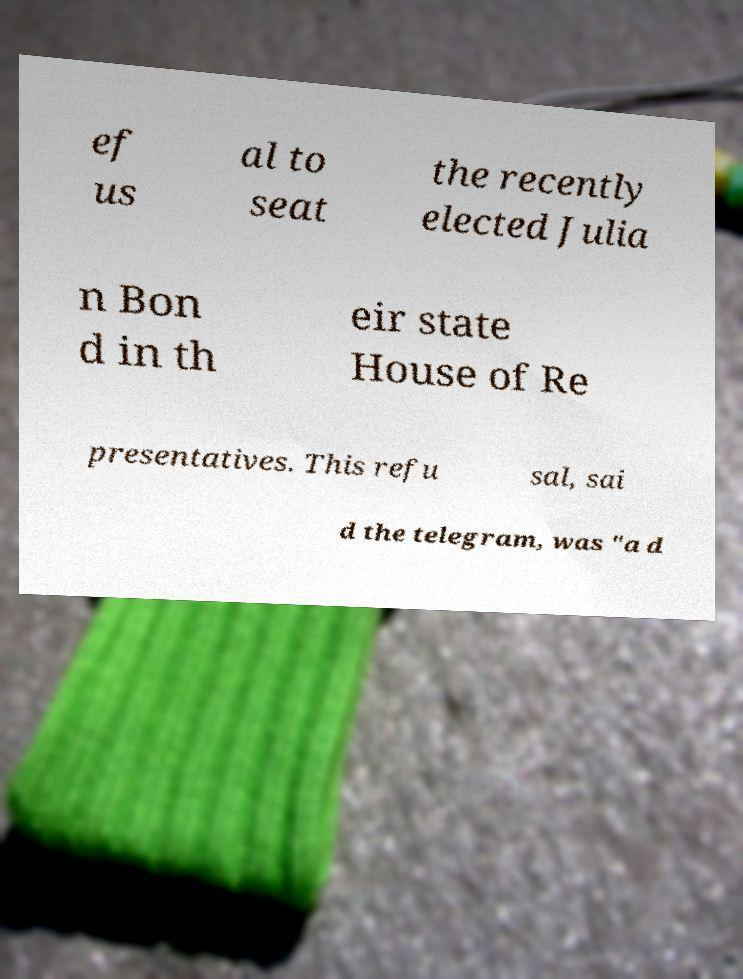Please read and relay the text visible in this image. What does it say? ef us al to seat the recently elected Julia n Bon d in th eir state House of Re presentatives. This refu sal, sai d the telegram, was "a d 